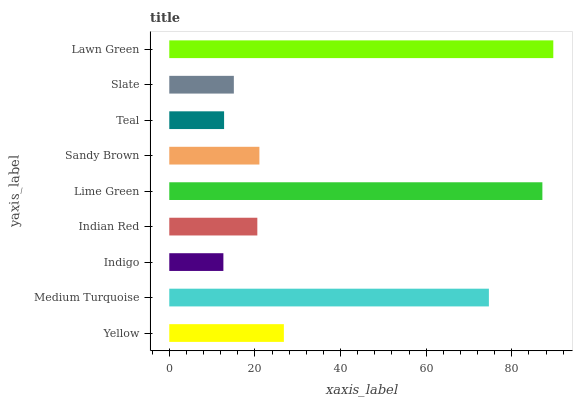Is Indigo the minimum?
Answer yes or no. Yes. Is Lawn Green the maximum?
Answer yes or no. Yes. Is Medium Turquoise the minimum?
Answer yes or no. No. Is Medium Turquoise the maximum?
Answer yes or no. No. Is Medium Turquoise greater than Yellow?
Answer yes or no. Yes. Is Yellow less than Medium Turquoise?
Answer yes or no. Yes. Is Yellow greater than Medium Turquoise?
Answer yes or no. No. Is Medium Turquoise less than Yellow?
Answer yes or no. No. Is Sandy Brown the high median?
Answer yes or no. Yes. Is Sandy Brown the low median?
Answer yes or no. Yes. Is Medium Turquoise the high median?
Answer yes or no. No. Is Indian Red the low median?
Answer yes or no. No. 